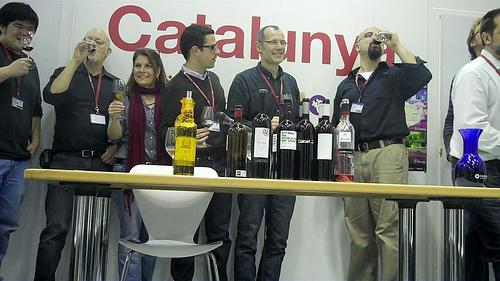What animal name does the first three letters on the wall spell? cat 